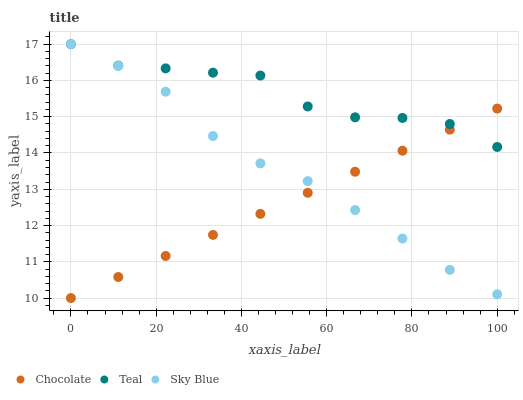Does Chocolate have the minimum area under the curve?
Answer yes or no. Yes. Does Teal have the maximum area under the curve?
Answer yes or no. Yes. Does Teal have the minimum area under the curve?
Answer yes or no. No. Does Chocolate have the maximum area under the curve?
Answer yes or no. No. Is Chocolate the smoothest?
Answer yes or no. Yes. Is Teal the roughest?
Answer yes or no. Yes. Is Teal the smoothest?
Answer yes or no. No. Is Chocolate the roughest?
Answer yes or no. No. Does Chocolate have the lowest value?
Answer yes or no. Yes. Does Teal have the lowest value?
Answer yes or no. No. Does Teal have the highest value?
Answer yes or no. Yes. Does Chocolate have the highest value?
Answer yes or no. No. Does Teal intersect Chocolate?
Answer yes or no. Yes. Is Teal less than Chocolate?
Answer yes or no. No. Is Teal greater than Chocolate?
Answer yes or no. No. 